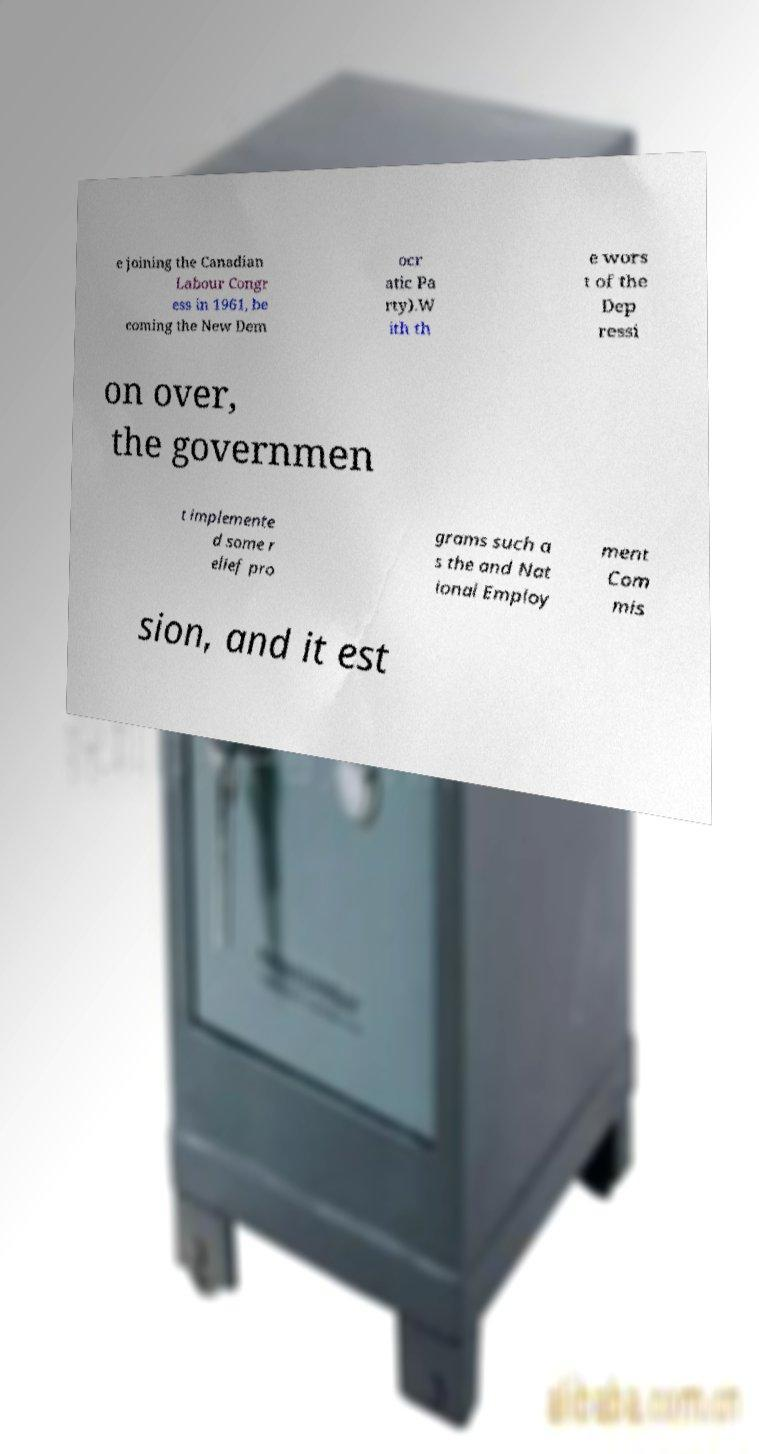Please identify and transcribe the text found in this image. e joining the Canadian Labour Congr ess in 1961, be coming the New Dem ocr atic Pa rty).W ith th e wors t of the Dep ressi on over, the governmen t implemente d some r elief pro grams such a s the and Nat ional Employ ment Com mis sion, and it est 